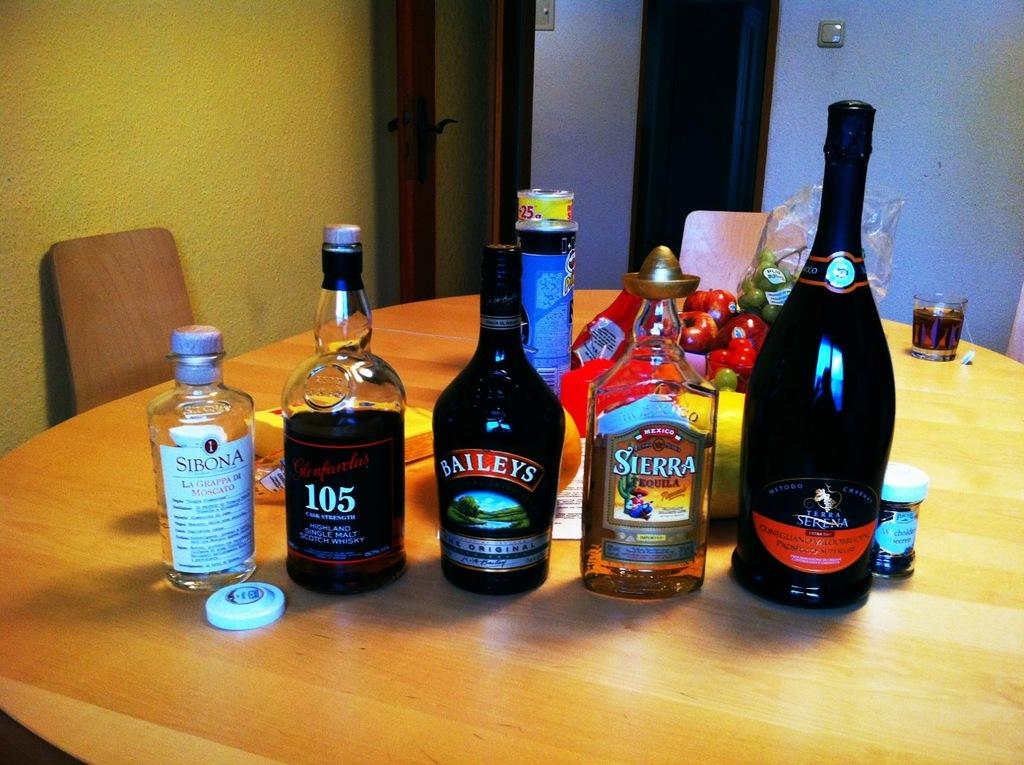<image>
Describe the image concisely. Some beverage containers including Sibona, Baileys and Sierra. 